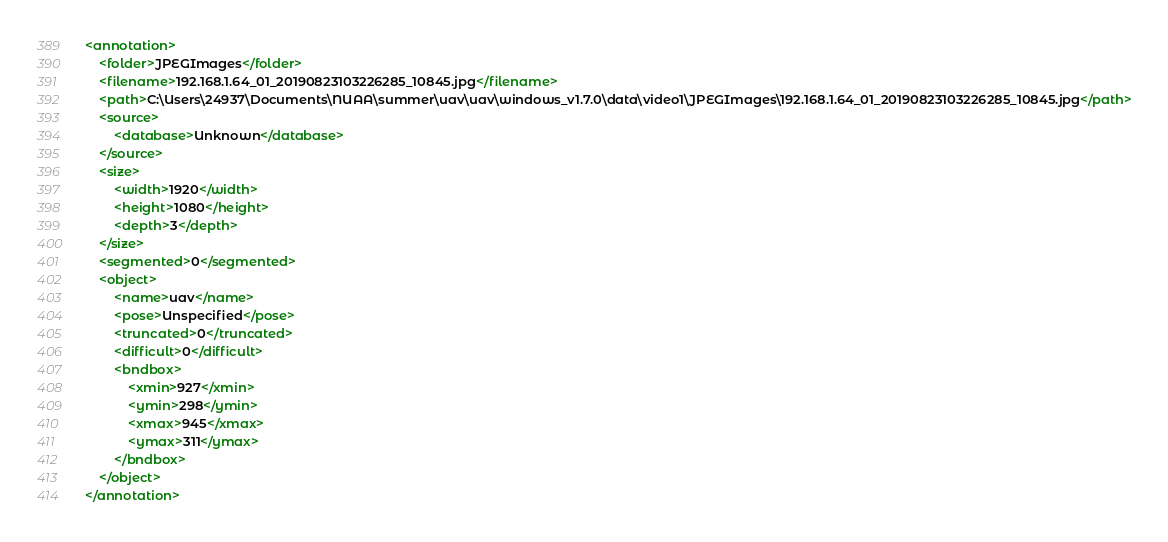<code> <loc_0><loc_0><loc_500><loc_500><_XML_><annotation>
	<folder>JPEGImages</folder>
	<filename>192.168.1.64_01_20190823103226285_10845.jpg</filename>
	<path>C:\Users\24937\Documents\NUAA\summer\uav\uav\windows_v1.7.0\data\video1\JPEGImages\192.168.1.64_01_20190823103226285_10845.jpg</path>
	<source>
		<database>Unknown</database>
	</source>
	<size>
		<width>1920</width>
		<height>1080</height>
		<depth>3</depth>
	</size>
	<segmented>0</segmented>
	<object>
		<name>uav</name>
		<pose>Unspecified</pose>
		<truncated>0</truncated>
		<difficult>0</difficult>
		<bndbox>
			<xmin>927</xmin>
			<ymin>298</ymin>
			<xmax>945</xmax>
			<ymax>311</ymax>
		</bndbox>
	</object>
</annotation>
</code> 